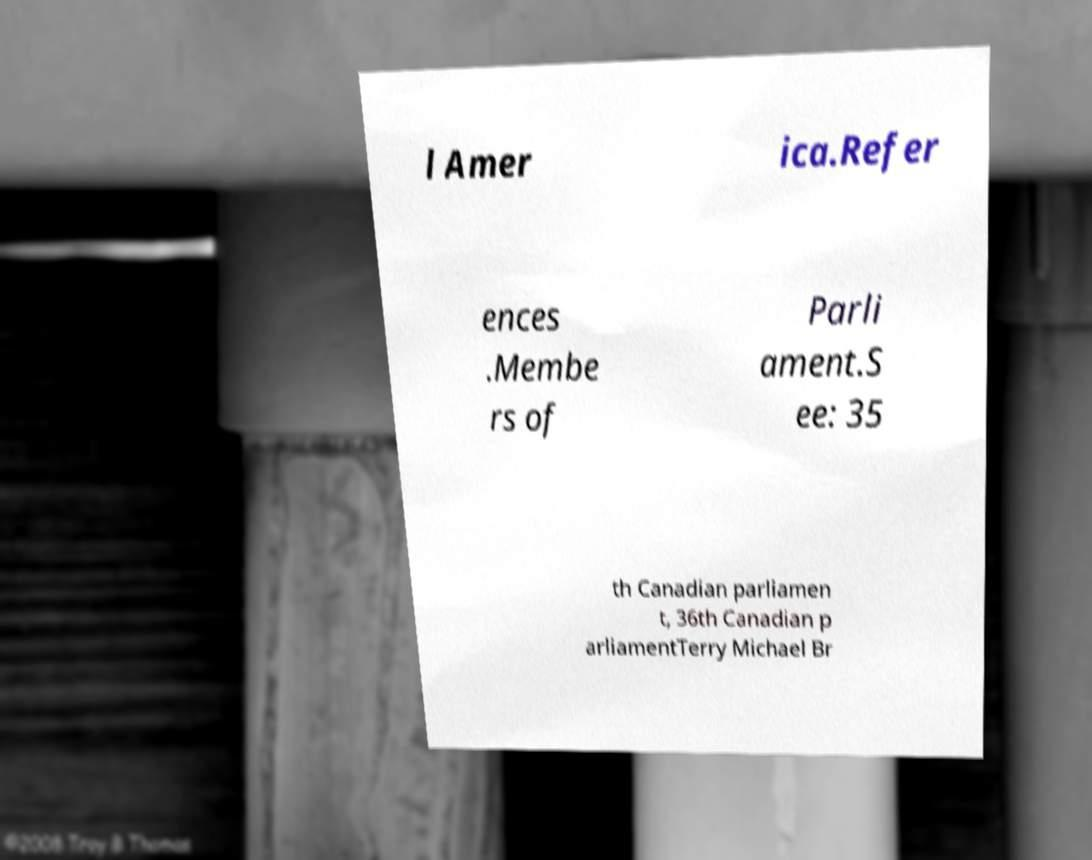Please read and relay the text visible in this image. What does it say? l Amer ica.Refer ences .Membe rs of Parli ament.S ee: 35 th Canadian parliamen t, 36th Canadian p arliamentTerry Michael Br 